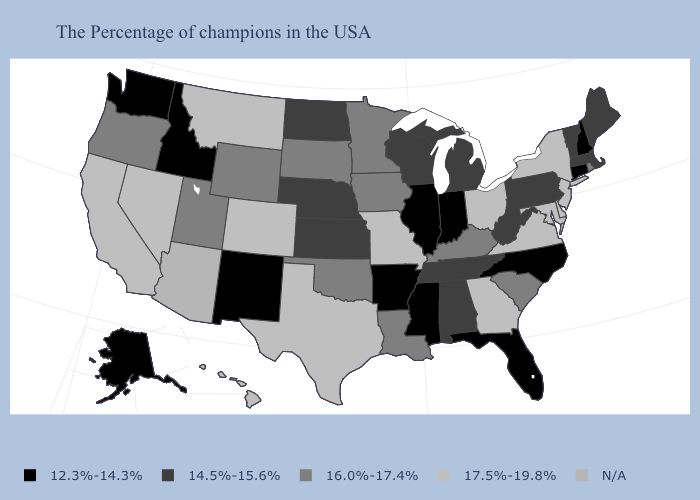Which states hav the highest value in the South?
Concise answer only. Delaware, Maryland, Virginia, Georgia, Texas. Name the states that have a value in the range 16.0%-17.4%?
Answer briefly. Rhode Island, South Carolina, Kentucky, Louisiana, Minnesota, Iowa, Oklahoma, South Dakota, Wyoming, Utah, Oregon. Does New Hampshire have the lowest value in the USA?
Short answer required. Yes. Which states hav the highest value in the West?
Give a very brief answer. Colorado, Montana, Nevada, California, Hawaii. What is the highest value in the USA?
Concise answer only. 17.5%-19.8%. What is the value of Arkansas?
Write a very short answer. 12.3%-14.3%. Does Delaware have the highest value in the USA?
Write a very short answer. Yes. What is the value of Louisiana?
Write a very short answer. 16.0%-17.4%. What is the value of Arizona?
Answer briefly. N/A. What is the highest value in the USA?
Short answer required. 17.5%-19.8%. What is the value of North Carolina?
Quick response, please. 12.3%-14.3%. What is the highest value in the USA?
Concise answer only. 17.5%-19.8%. Does Kansas have the lowest value in the MidWest?
Concise answer only. No. 